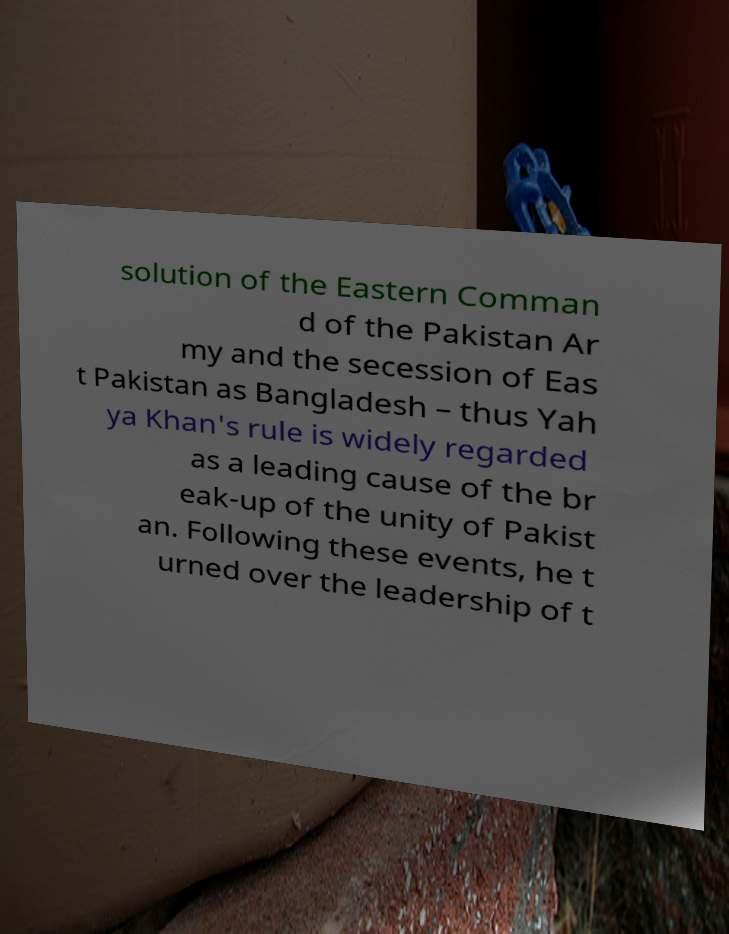Could you extract and type out the text from this image? solution of the Eastern Comman d of the Pakistan Ar my and the secession of Eas t Pakistan as Bangladesh – thus Yah ya Khan's rule is widely regarded as a leading cause of the br eak-up of the unity of Pakist an. Following these events, he t urned over the leadership of t 